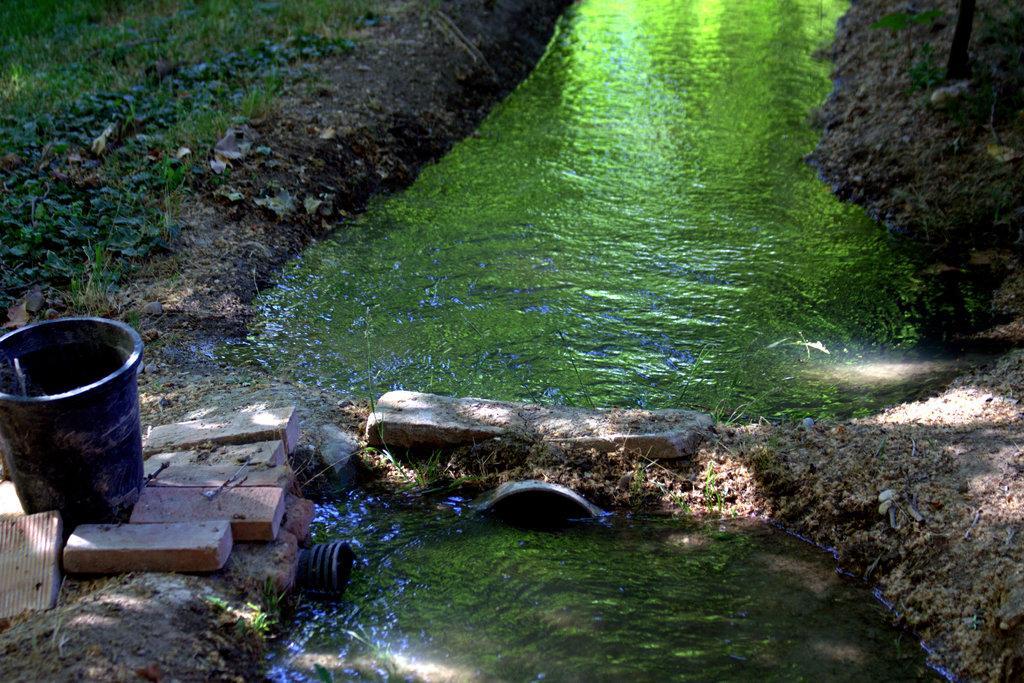Can you describe this image briefly? In this image I can see a container, bricks and grass on the left. There is water in the center. 